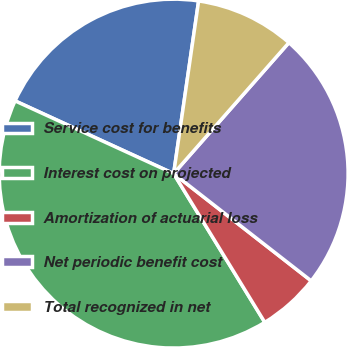<chart> <loc_0><loc_0><loc_500><loc_500><pie_chart><fcel>Service cost for benefits<fcel>Interest cost on projected<fcel>Amortization of actuarial loss<fcel>Net periodic benefit cost<fcel>Total recognized in net<nl><fcel>20.44%<fcel>40.59%<fcel>5.71%<fcel>24.05%<fcel>9.2%<nl></chart> 